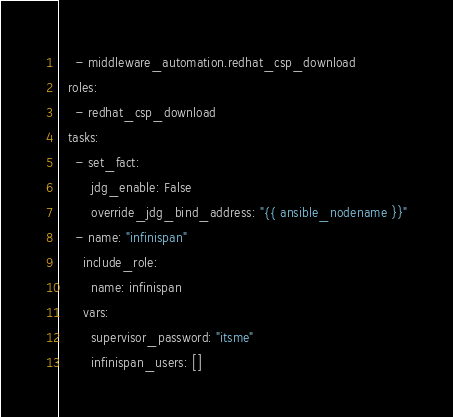<code> <loc_0><loc_0><loc_500><loc_500><_YAML_>    - middleware_automation.redhat_csp_download
  roles:
    - redhat_csp_download
  tasks:
    - set_fact:
        jdg_enable: False
        override_jdg_bind_address: "{{ ansible_nodename }}"
    - name: "infinispan"
      include_role:
        name: infinispan
      vars:
        supervisor_password: "itsme"
        infinispan_users: []
</code> 